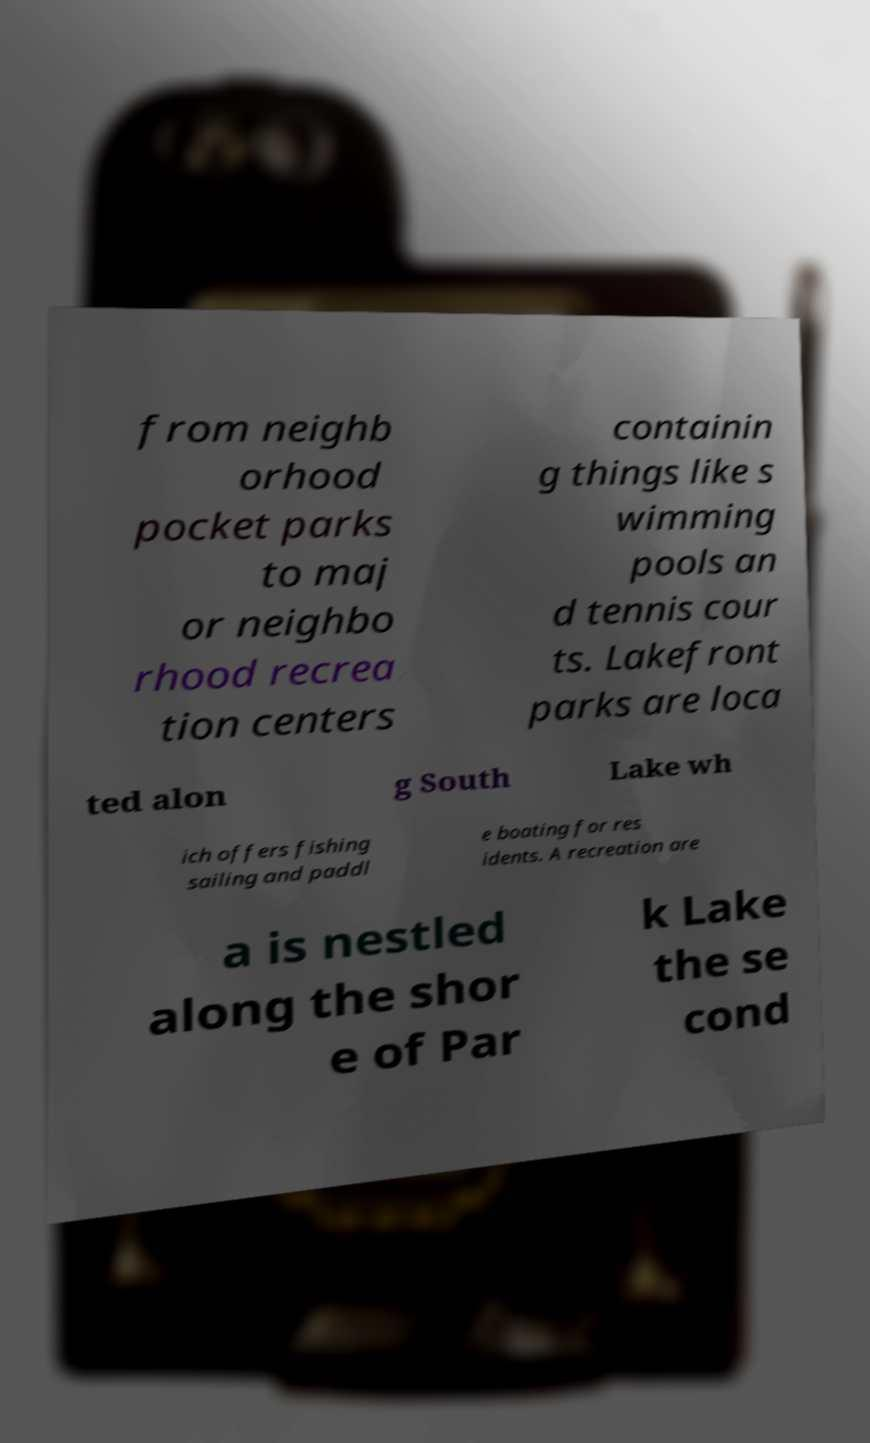What messages or text are displayed in this image? I need them in a readable, typed format. from neighb orhood pocket parks to maj or neighbo rhood recrea tion centers containin g things like s wimming pools an d tennis cour ts. Lakefront parks are loca ted alon g South Lake wh ich offers fishing sailing and paddl e boating for res idents. A recreation are a is nestled along the shor e of Par k Lake the se cond 